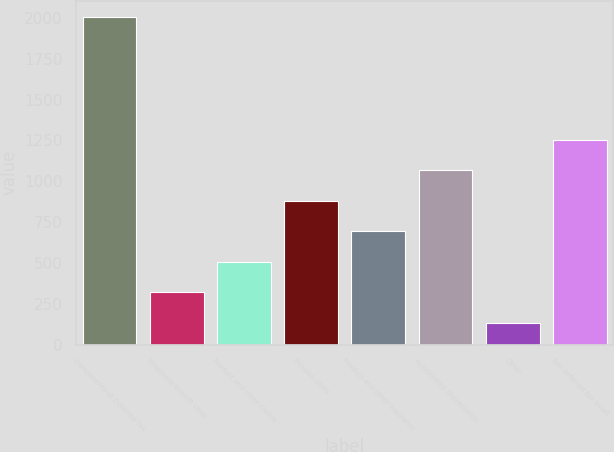<chart> <loc_0><loc_0><loc_500><loc_500><bar_chart><fcel>Components of Deferred Tax<fcel>Employee benefit costs<fcel>Product and other claims<fcel>Pension costs<fcel>Product and other insurance<fcel>Accelerated depreciation<fcel>Other<fcel>Net deferred tax asset<nl><fcel>2004<fcel>320.1<fcel>507.2<fcel>881.4<fcel>694.3<fcel>1068.5<fcel>133<fcel>1255.6<nl></chart> 